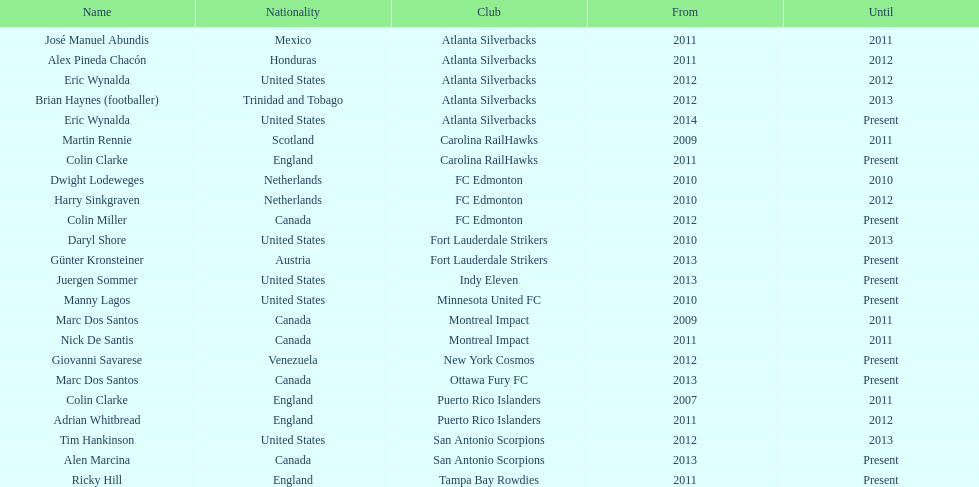How many total coaches on the list are from canada? 5. 